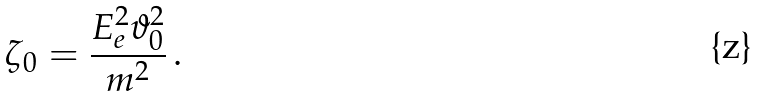Convert formula to latex. <formula><loc_0><loc_0><loc_500><loc_500>\zeta _ { 0 } = \frac { E _ { e } ^ { 2 } \vartheta _ { 0 } ^ { 2 } } { m ^ { 2 } } \, .</formula> 